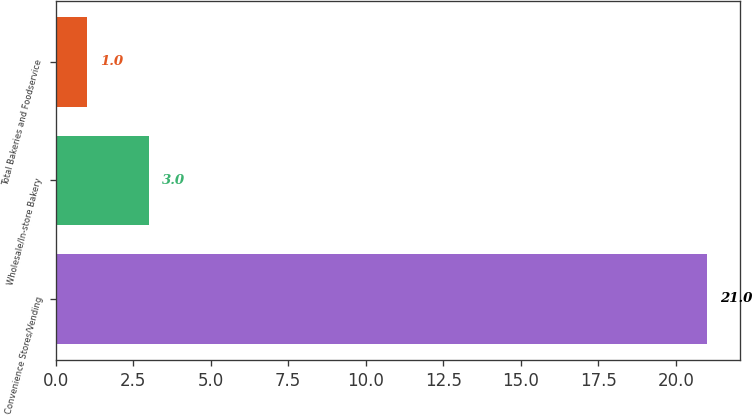Convert chart. <chart><loc_0><loc_0><loc_500><loc_500><bar_chart><fcel>Convenience Stores/Vending<fcel>Wholesale/In-store Bakery<fcel>Total Bakeries and Foodservice<nl><fcel>21<fcel>3<fcel>1<nl></chart> 